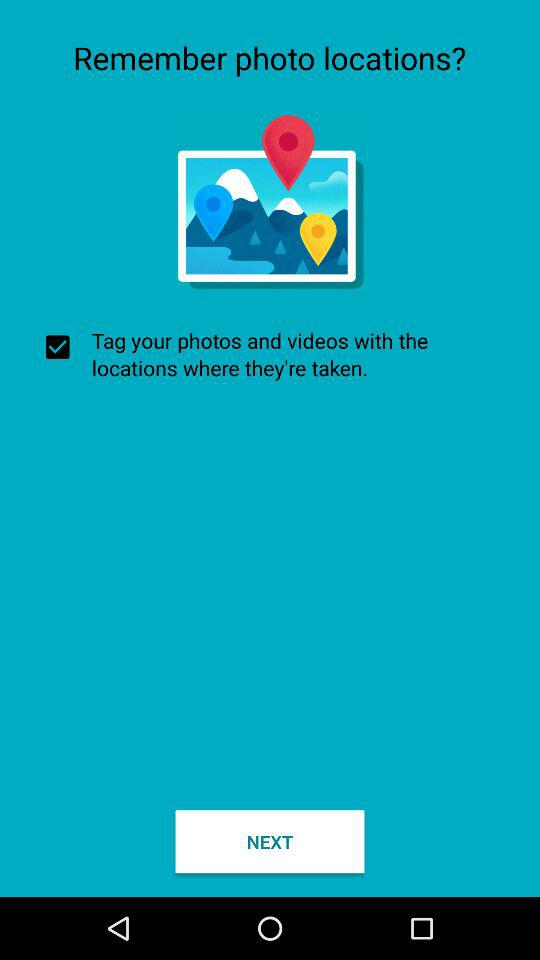What is the status of the "Tag your photos and videos"? The status is "on". 